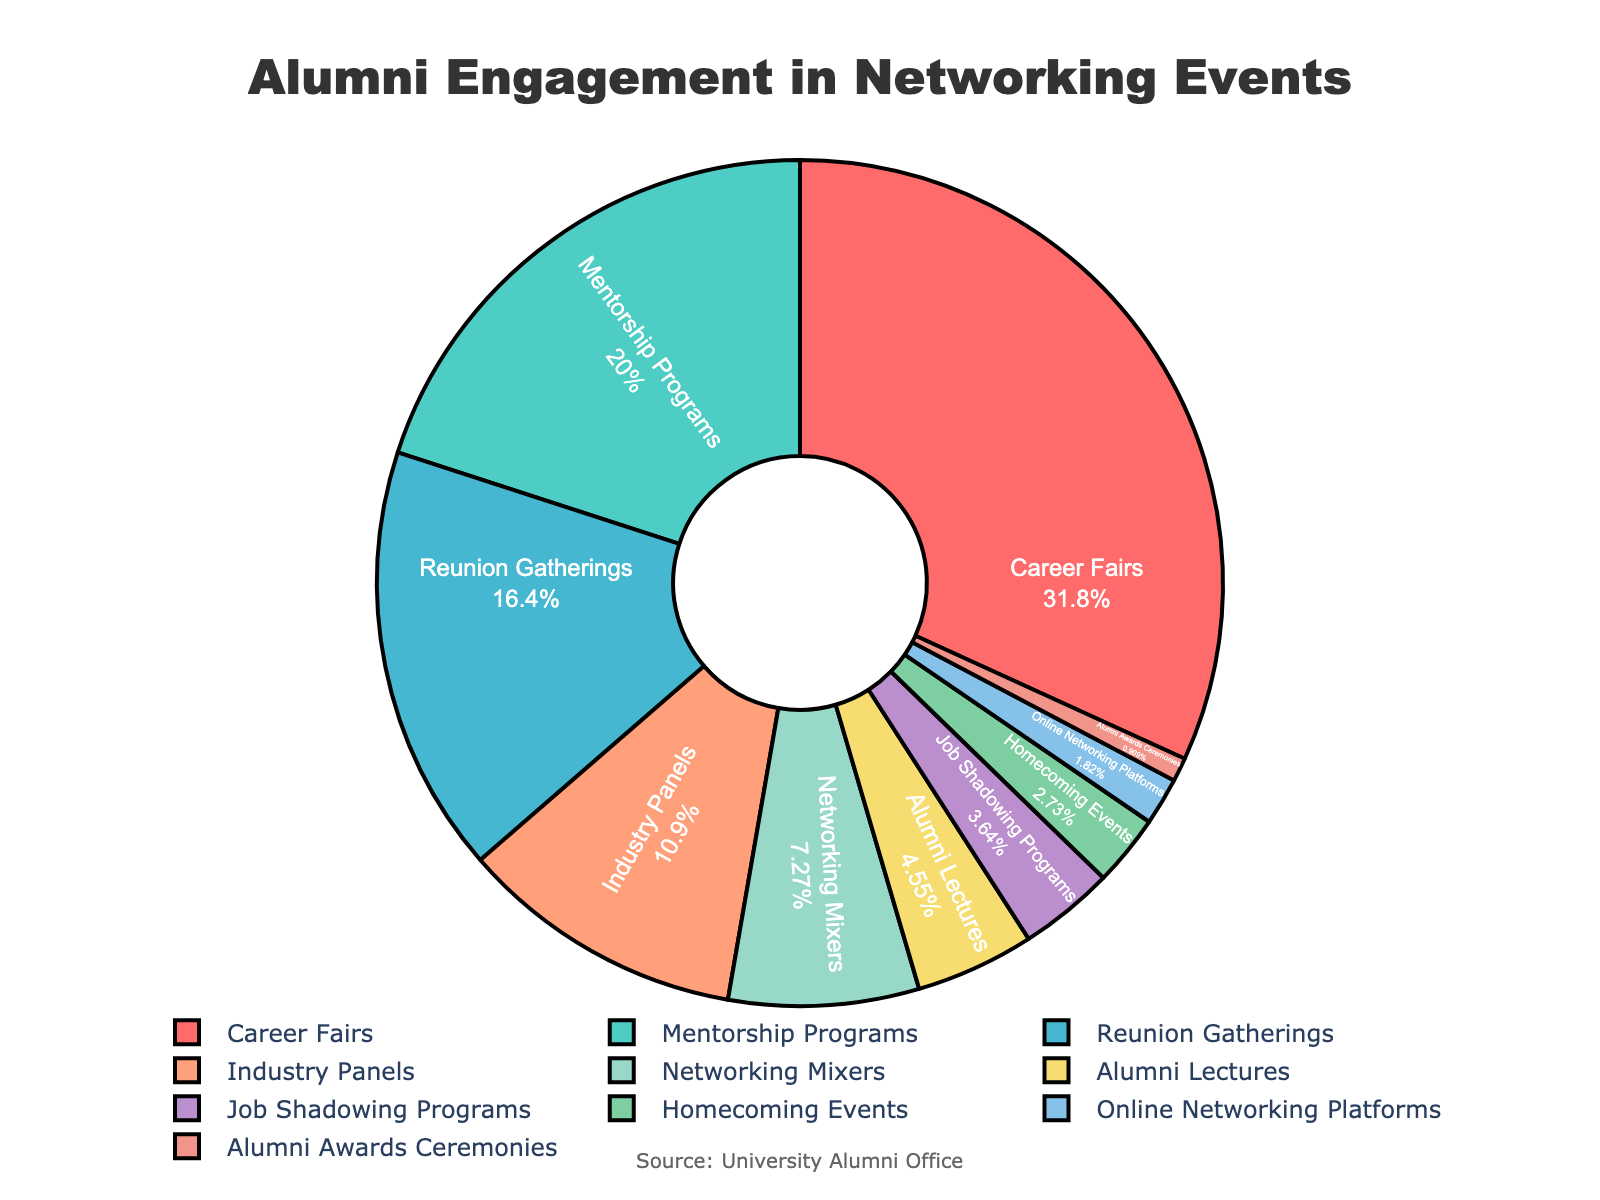Which event type has the highest percentage of alumni engagement? The pie chart shows that Career Fairs have the largest segment.
Answer: Career Fairs Which event type has the lowest percentage of alumni engagement? The pie chart shows that Alumni Awards Ceremonies have the smallest segment.
Answer: Alumni Awards Ceremonies What is the combined percentage of alumni engagement for Mentorship Programs and Industry Panels? Mentorship Programs have 22% and Industry Panels have 12%. Adding these together gives 22% + 12% = 34%.
Answer: 34% Is the engagement in Reunion Gatherings greater than that in Networking Mixers? The pie chart shows that Reunion Gatherings have 18%, while Networking Mixers have 8%. Since 18% is greater than 8%, the answer is yes.
Answer: Yes Which events have an engagement percentage of less than 5%? The pie chart's segments show that Job Shadowing Programs (4%), Homecoming Events (3%), Online Networking Platforms (2%), and Alumni Awards Ceremonies (1%) each have less than 5%.
Answer: Job Shadowing Programs, Homecoming Events, Online Networking Platforms, Alumni Awards Ceremonies How much more engagement do Career Fairs have compared to Alumni Lectures? Career Fairs have 35% engagement and Alumni Lectures have 5%. The difference is 35% - 5% = 30%.
Answer: 30% Which two event types together make up almost half of the alumni engagement? Career Fairs have 35% and Mentorship Programs have 22%. Together this is 35% + 22% = 57%, which is more than half. The next combination closer to half would be Career Fairs and Industry Panels: 35% + 12% = 47%.
Answer: Career Fairs and Industry Panels Are there more alumni engaged in Career Fairs than in Mentorship Programs and Networking Mixers combined? Mentorship Programs have 22% and Networking Mixers have 8%. Combined, they have 22% + 8% = 30%. Career Fairs have 35%, which is more than 30%.
Answer: Yes What is the total percentage of engagement for events related to direct professional development (Career Fairs, Mentorship Programs, Industry Panels, Job Shadowing Programs)? Career Fairs (35%), Mentorship Programs (22%), Industry Panels (12%), and Job Shadowing Programs (4%) have a combined total of 35% + 22% + 12% + 4% = 73%.
Answer: 73% 